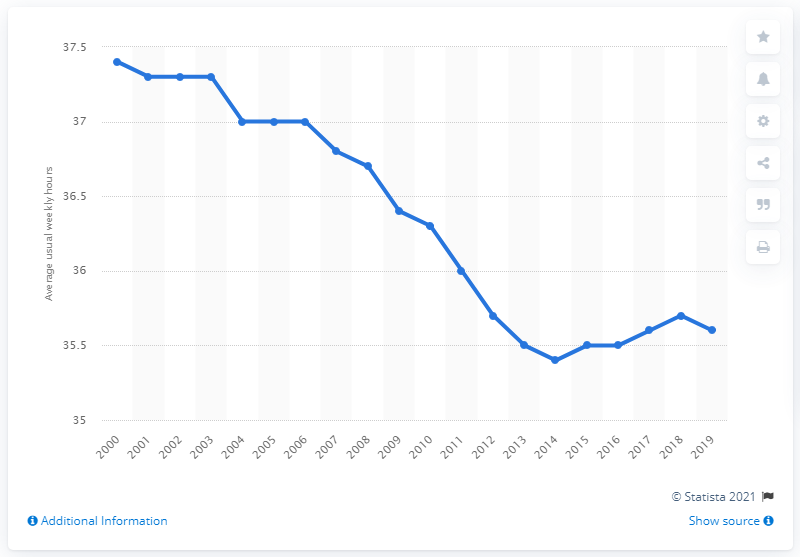Highlight a few significant elements in this photo. In Italy in 2019, the average weekly hours worked on the main job was 35.6 hours. In 2000, the average number of weekly working hours in Italy was 37.4 hours. 